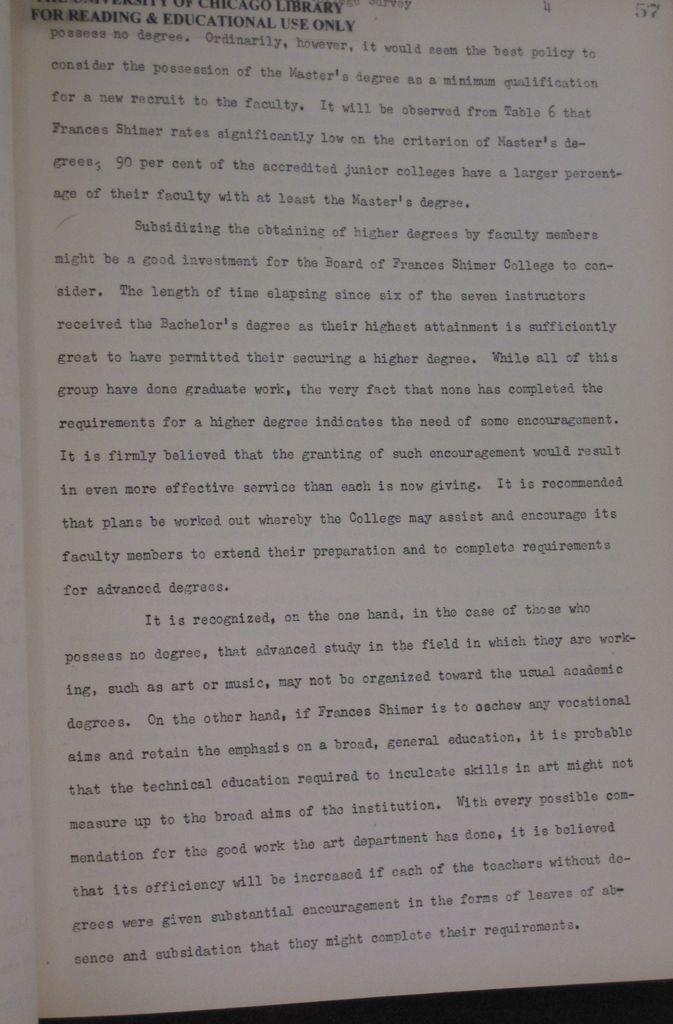What should be subsidized for the board to consider?
Offer a terse response. The obtaining of higher degrees by faculty members. 